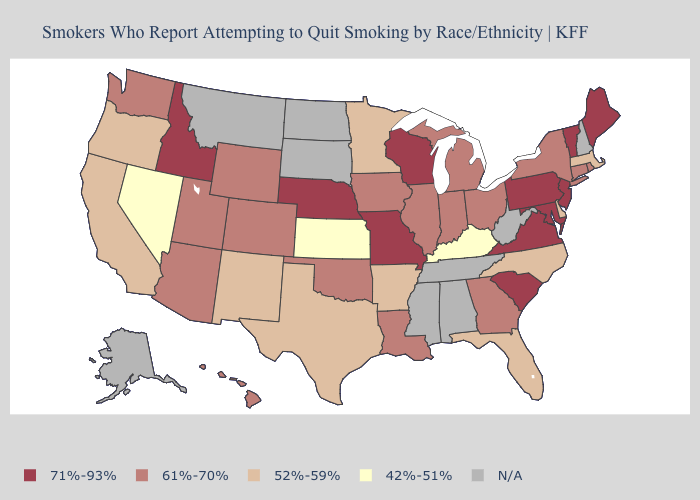What is the highest value in states that border Michigan?
Answer briefly. 71%-93%. Name the states that have a value in the range 42%-51%?
Short answer required. Kansas, Kentucky, Nevada. Does Wisconsin have the highest value in the MidWest?
Answer briefly. Yes. Which states hav the highest value in the Northeast?
Answer briefly. Maine, New Jersey, Pennsylvania, Vermont. Name the states that have a value in the range 61%-70%?
Write a very short answer. Arizona, Colorado, Connecticut, Georgia, Hawaii, Illinois, Indiana, Iowa, Louisiana, Michigan, New York, Ohio, Oklahoma, Rhode Island, Utah, Washington, Wyoming. Does Louisiana have the highest value in the USA?
Answer briefly. No. What is the lowest value in the USA?
Answer briefly. 42%-51%. Which states have the highest value in the USA?
Short answer required. Idaho, Maine, Maryland, Missouri, Nebraska, New Jersey, Pennsylvania, South Carolina, Vermont, Virginia, Wisconsin. Does the map have missing data?
Concise answer only. Yes. Name the states that have a value in the range 52%-59%?
Give a very brief answer. Arkansas, California, Delaware, Florida, Massachusetts, Minnesota, New Mexico, North Carolina, Oregon, Texas. What is the highest value in states that border Virginia?
Be succinct. 71%-93%. Name the states that have a value in the range 52%-59%?
Answer briefly. Arkansas, California, Delaware, Florida, Massachusetts, Minnesota, New Mexico, North Carolina, Oregon, Texas. What is the value of Hawaii?
Write a very short answer. 61%-70%. 